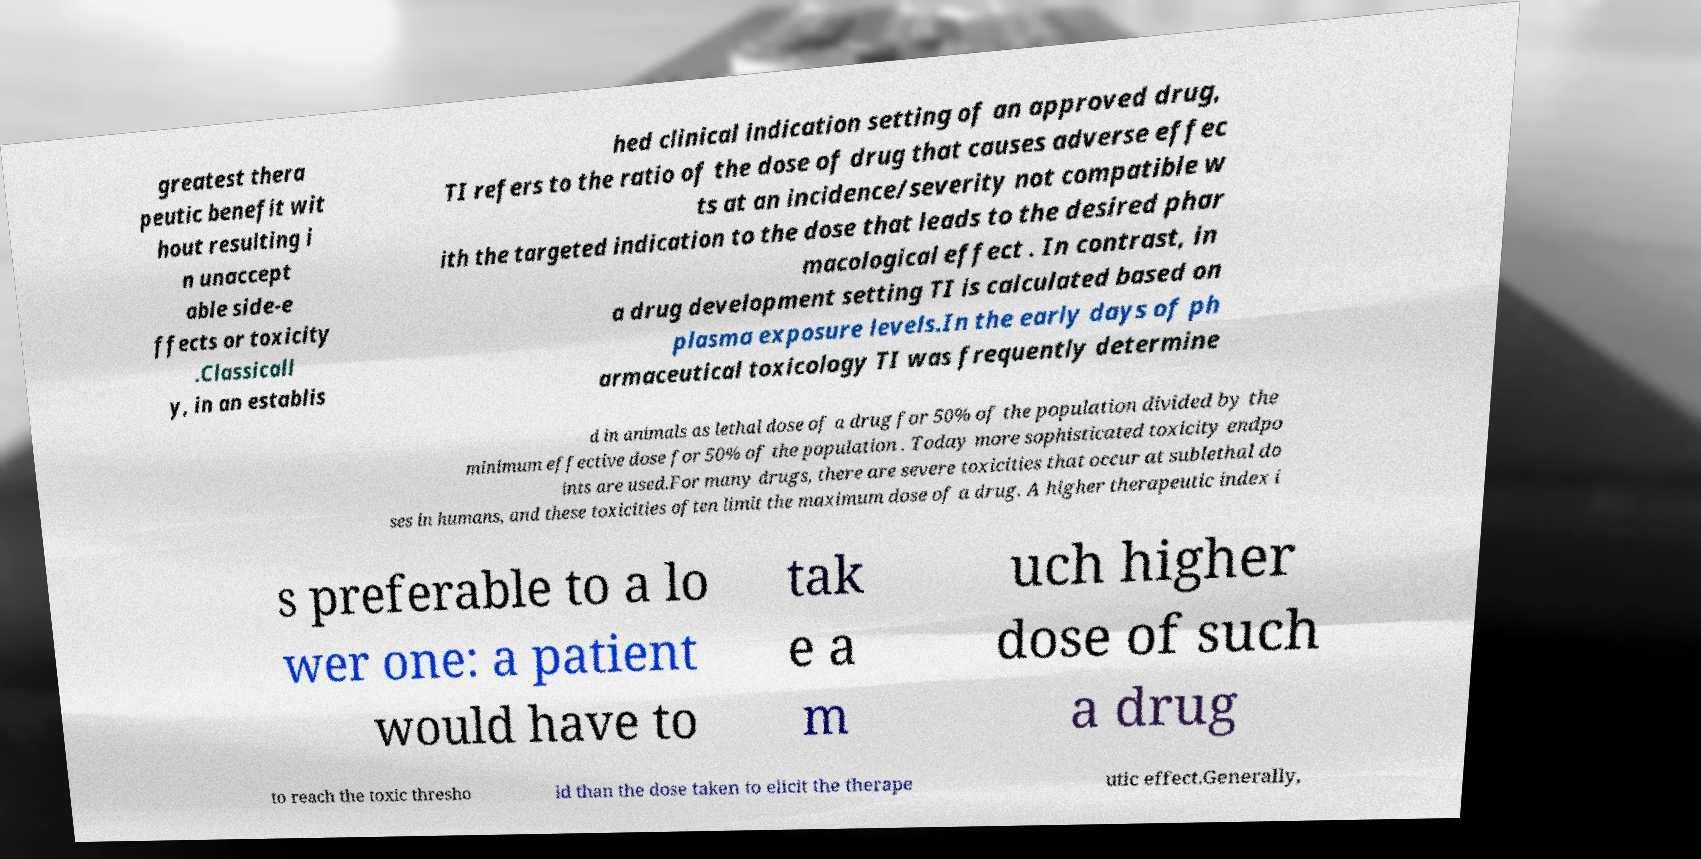Can you accurately transcribe the text from the provided image for me? greatest thera peutic benefit wit hout resulting i n unaccept able side-e ffects or toxicity .Classicall y, in an establis hed clinical indication setting of an approved drug, TI refers to the ratio of the dose of drug that causes adverse effec ts at an incidence/severity not compatible w ith the targeted indication to the dose that leads to the desired phar macological effect . In contrast, in a drug development setting TI is calculated based on plasma exposure levels.In the early days of ph armaceutical toxicology TI was frequently determine d in animals as lethal dose of a drug for 50% of the population divided by the minimum effective dose for 50% of the population . Today more sophisticated toxicity endpo ints are used.For many drugs, there are severe toxicities that occur at sublethal do ses in humans, and these toxicities often limit the maximum dose of a drug. A higher therapeutic index i s preferable to a lo wer one: a patient would have to tak e a m uch higher dose of such a drug to reach the toxic thresho ld than the dose taken to elicit the therape utic effect.Generally, 